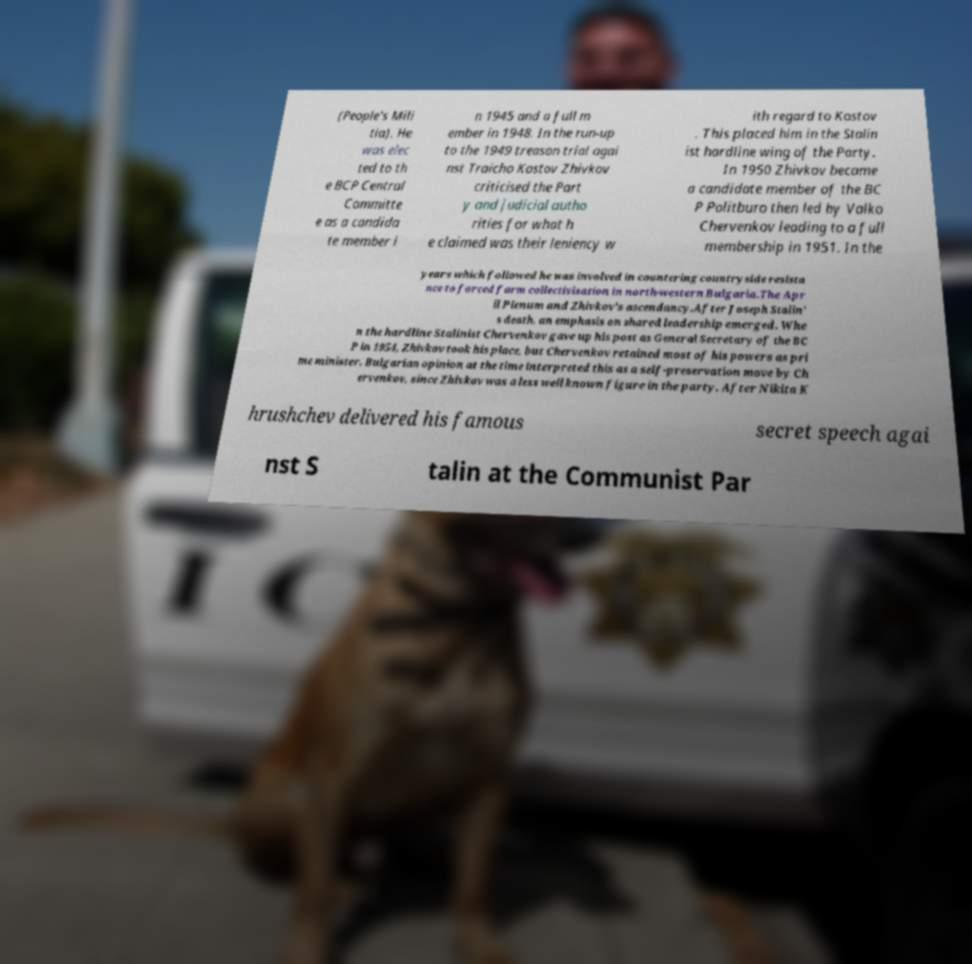Can you read and provide the text displayed in the image?This photo seems to have some interesting text. Can you extract and type it out for me? (People's Mili tia). He was elec ted to th e BCP Central Committe e as a candida te member i n 1945 and a full m ember in 1948. In the run-up to the 1949 treason trial agai nst Traicho Kostov Zhivkov criticised the Part y and judicial autho rities for what h e claimed was their leniency w ith regard to Kostov . This placed him in the Stalin ist hardline wing of the Party. In 1950 Zhivkov became a candidate member of the BC P Politburo then led by Valko Chervenkov leading to a full membership in 1951. In the years which followed he was involved in countering countryside resista nce to forced farm collectivisation in north-western Bulgaria.The Apr il Plenum and Zhivkov's ascendancy.After Joseph Stalin' s death, an emphasis on shared leadership emerged. Whe n the hardline Stalinist Chervenkov gave up his post as General Secretary of the BC P in 1954, Zhivkov took his place, but Chervenkov retained most of his powers as pri me minister. Bulgarian opinion at the time interpreted this as a self-preservation move by Ch ervenkov, since Zhivkov was a less well known figure in the party. After Nikita K hrushchev delivered his famous secret speech agai nst S talin at the Communist Par 